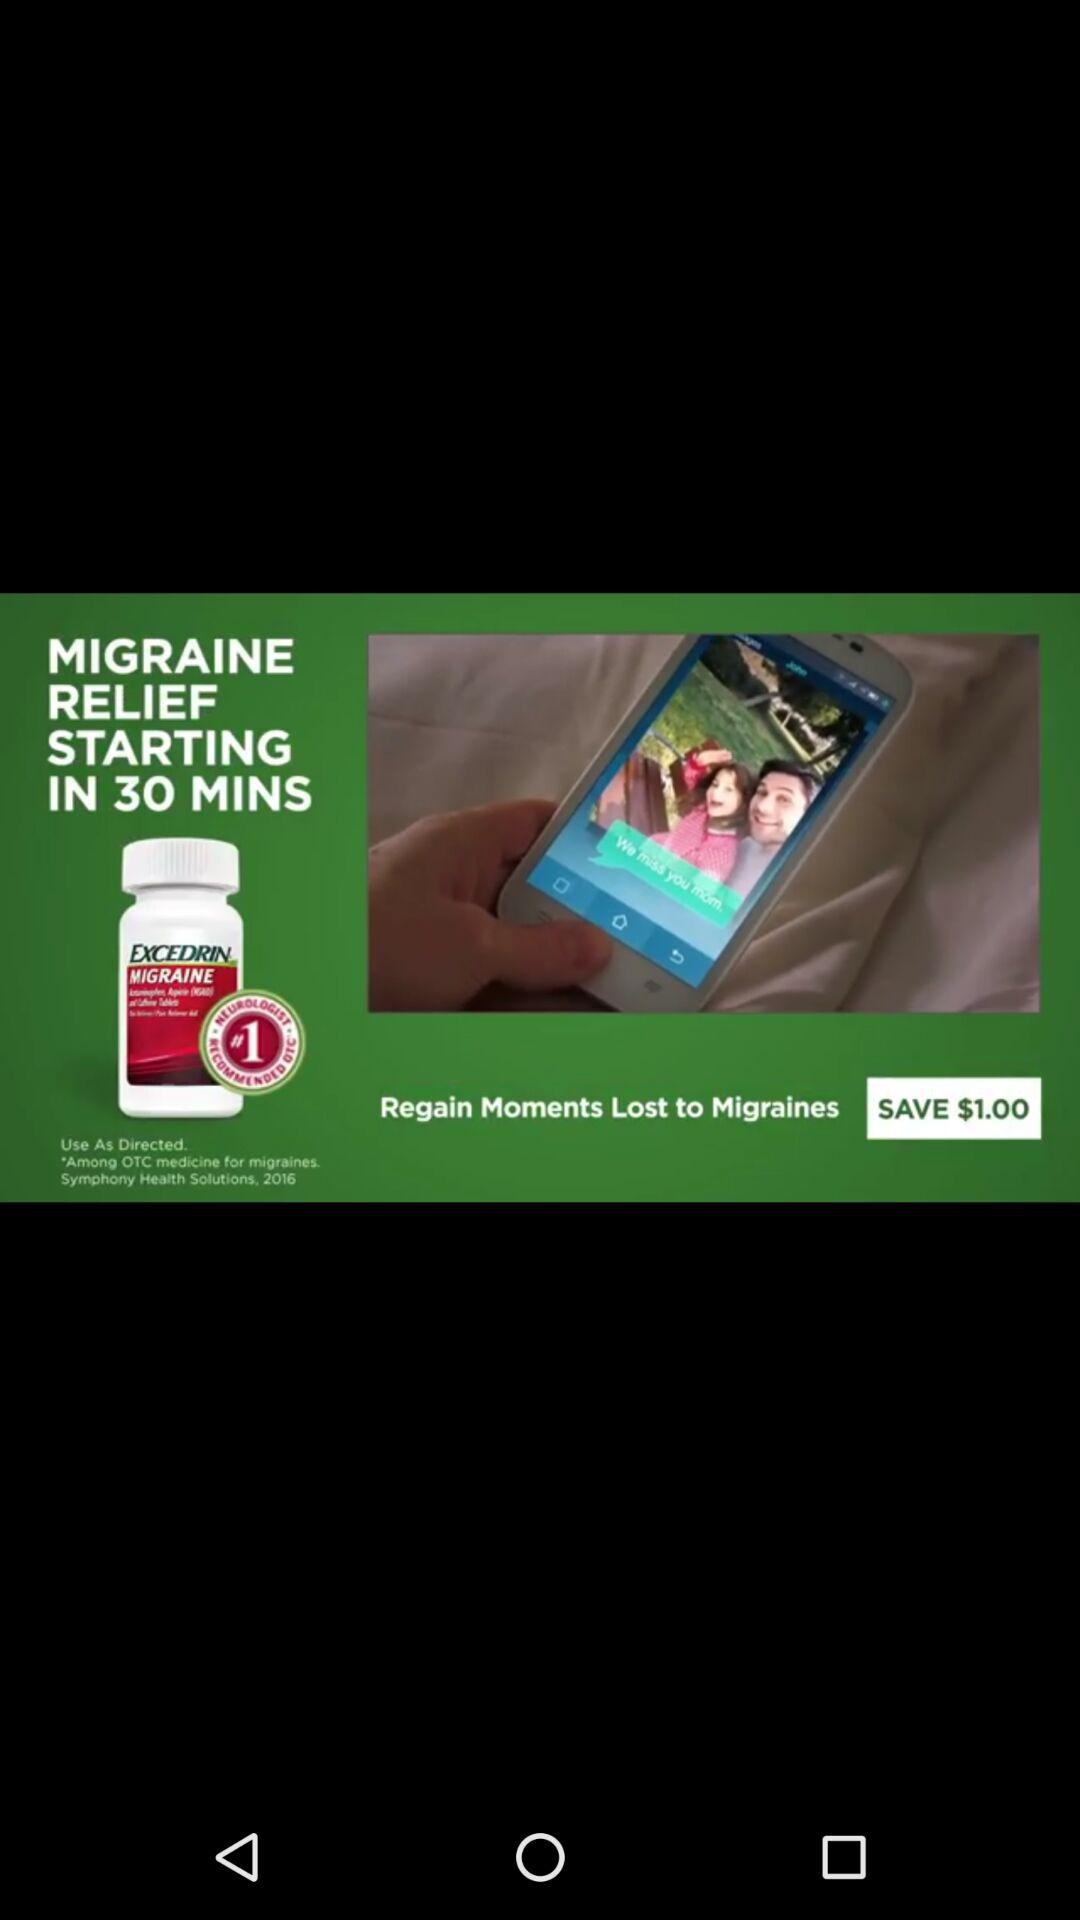How much is the savings on this product?
Answer the question using a single word or phrase. $1.00 